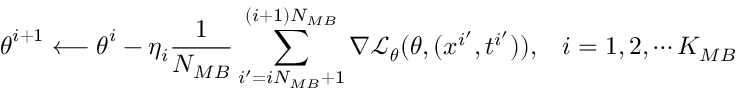Convert formula to latex. <formula><loc_0><loc_0><loc_500><loc_500>\theta ^ { i + 1 } \longleftarrow \theta ^ { i } - \eta _ { i } \frac { 1 } { N _ { M B } } \sum _ { i ^ { \prime } = i N _ { M B } + 1 } ^ { ( i + 1 ) N _ { M B } } \nabla \mathcal { L } _ { \theta } ( \theta , ( x ^ { i ^ { \prime } } , t ^ { i ^ { \prime } } ) ) , \, i = 1 , 2 , \cdots K _ { M B }</formula> 